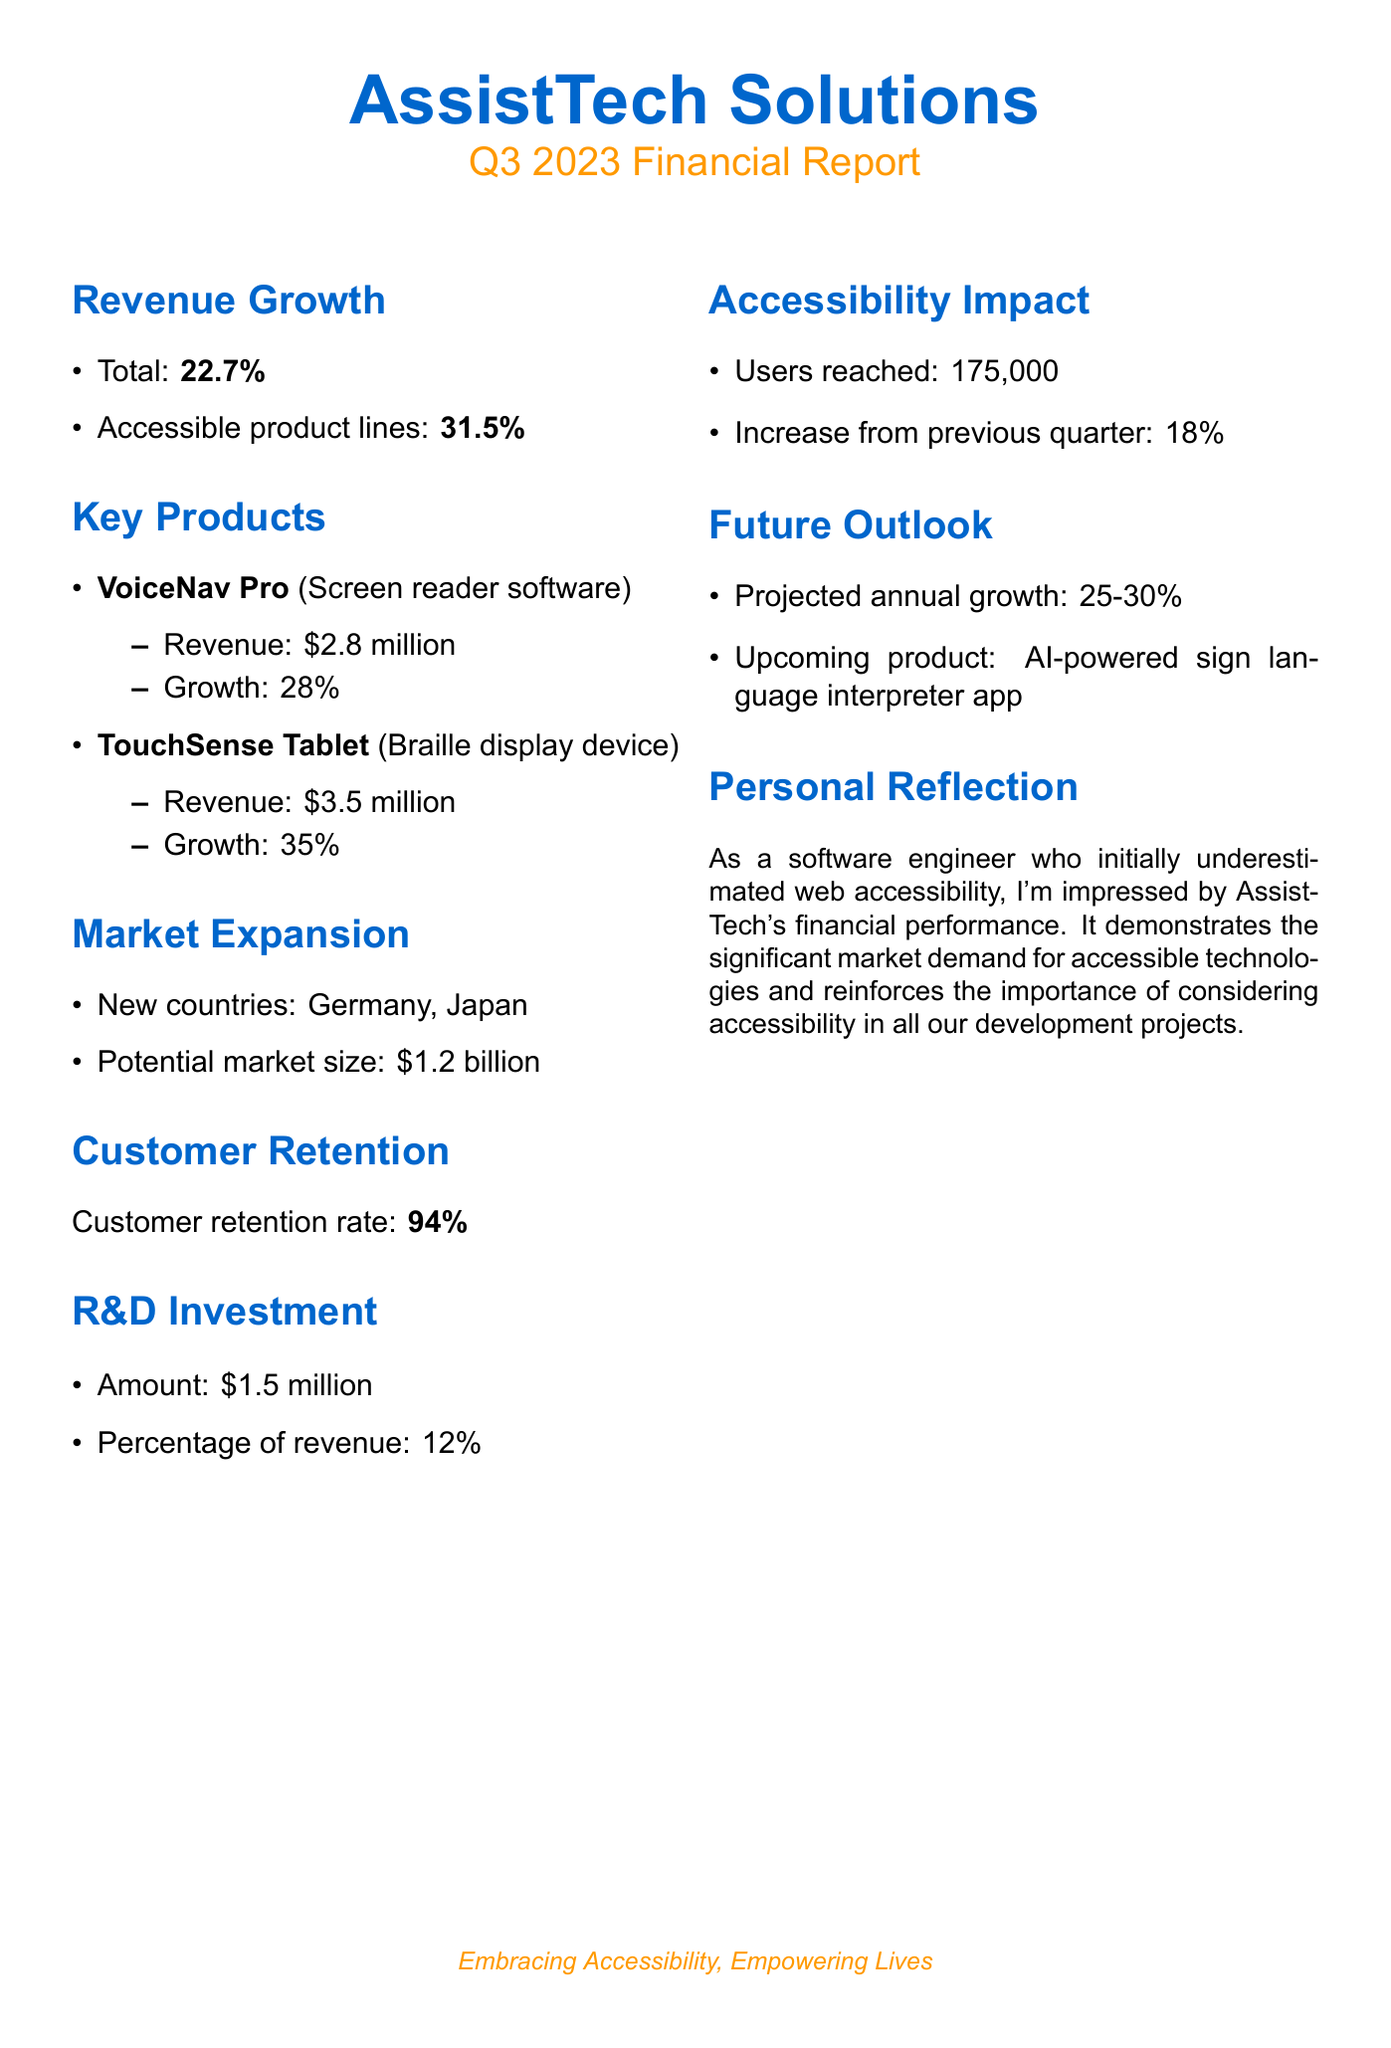What is the company name? The company name is provided at the beginning of the document.
Answer: AssistTech Solutions What is the revenue growth percentage for accessible product lines? The document specifically mentions the percentage increase for accessible product lines under the revenue growth section.
Answer: 31.5% How much revenue did VoiceNav Pro generate? The revenue generated by VoiceNav Pro is stated in the key products section of the document.
Answer: $2.8 million What is the customer retention rate for AssistTech Solutions? The customer retention rate is mentioned in the customer retention section.
Answer: 94% What is the potential market size mentioned in the market expansion section? The document lists the potential market size under the market expansion section.
Answer: $1.2 billion Which new countries is AssistTech expanding into? The new countries for market expansion are listed in the market expansion section.
Answer: Germany, Japan What is the projected annual growth rate? The projected annual growth rate is specified in the future outlook section of the document.
Answer: 25-30% How many users has AssistTech reached this quarter? The number of users reached is mentioned in the accessibility impact section of the report.
Answer: 175,000 What is the upcoming product mentioned for AssistTech? The upcoming product is provided in the future outlook section.
Answer: AI-powered sign language interpreter app 